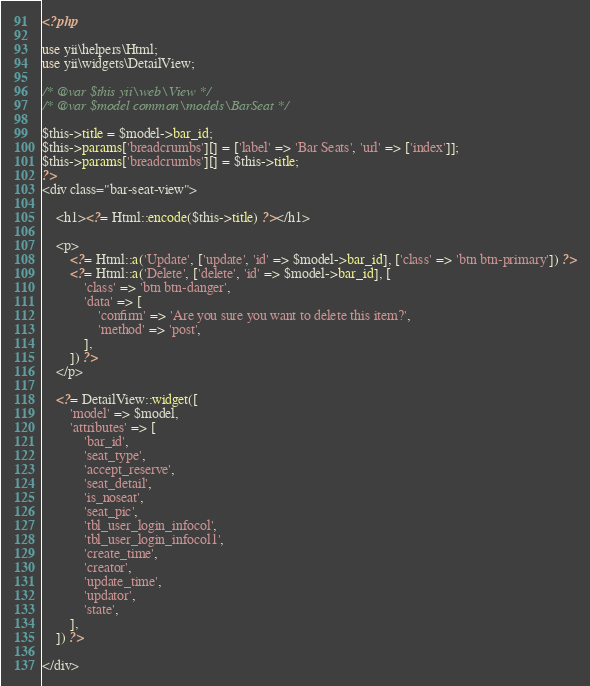Convert code to text. <code><loc_0><loc_0><loc_500><loc_500><_PHP_><?php

use yii\helpers\Html;
use yii\widgets\DetailView;

/* @var $this yii\web\View */
/* @var $model common\models\BarSeat */

$this->title = $model->bar_id;
$this->params['breadcrumbs'][] = ['label' => 'Bar Seats', 'url' => ['index']];
$this->params['breadcrumbs'][] = $this->title;
?>
<div class="bar-seat-view">

    <h1><?= Html::encode($this->title) ?></h1>

    <p>
        <?= Html::a('Update', ['update', 'id' => $model->bar_id], ['class' => 'btn btn-primary']) ?>
        <?= Html::a('Delete', ['delete', 'id' => $model->bar_id], [
            'class' => 'btn btn-danger',
            'data' => [
                'confirm' => 'Are you sure you want to delete this item?',
                'method' => 'post',
            ],
        ]) ?>
    </p>

    <?= DetailView::widget([
        'model' => $model,
        'attributes' => [
            'bar_id',
            'seat_type',
            'accept_reserve',
            'seat_detail',
            'is_noseat',
            'seat_pic',
            'tbl_user_login_infocol',
            'tbl_user_login_infocol1',
            'create_time',
            'creator',
            'update_time',
            'updator',
            'state',
        ],
    ]) ?>

</div>
</code> 